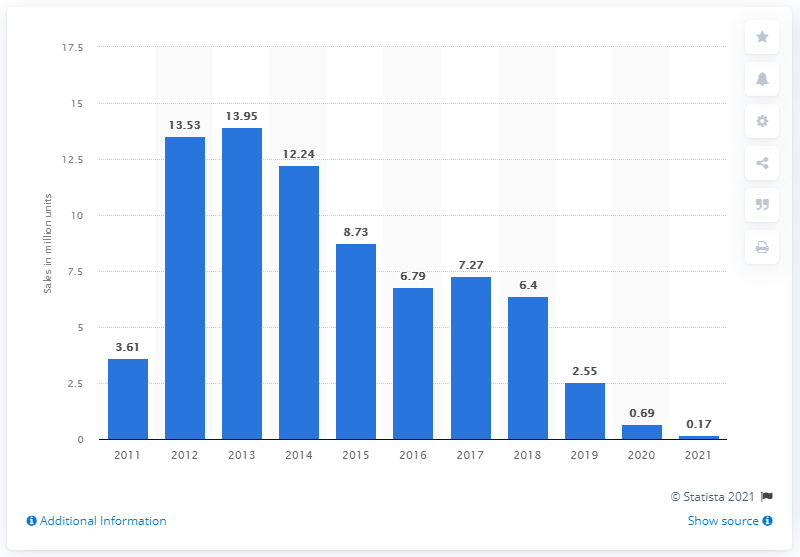Point out several critical features in this image. In the year prior, 0.69 million 3DS consoles were sold. 